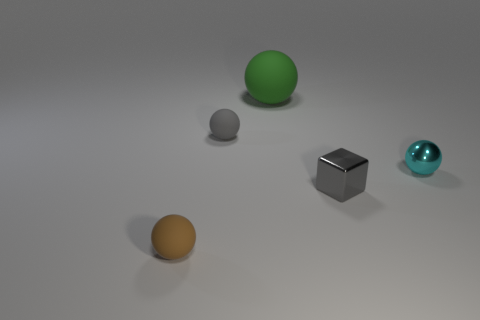Add 3 big spheres. How many objects exist? 8 Subtract all spheres. How many objects are left? 1 Add 2 tiny gray shiny cubes. How many tiny gray shiny cubes are left? 3 Add 2 tiny gray matte spheres. How many tiny gray matte spheres exist? 3 Subtract 0 red cubes. How many objects are left? 5 Subtract all small green cylinders. Subtract all cyan shiny objects. How many objects are left? 4 